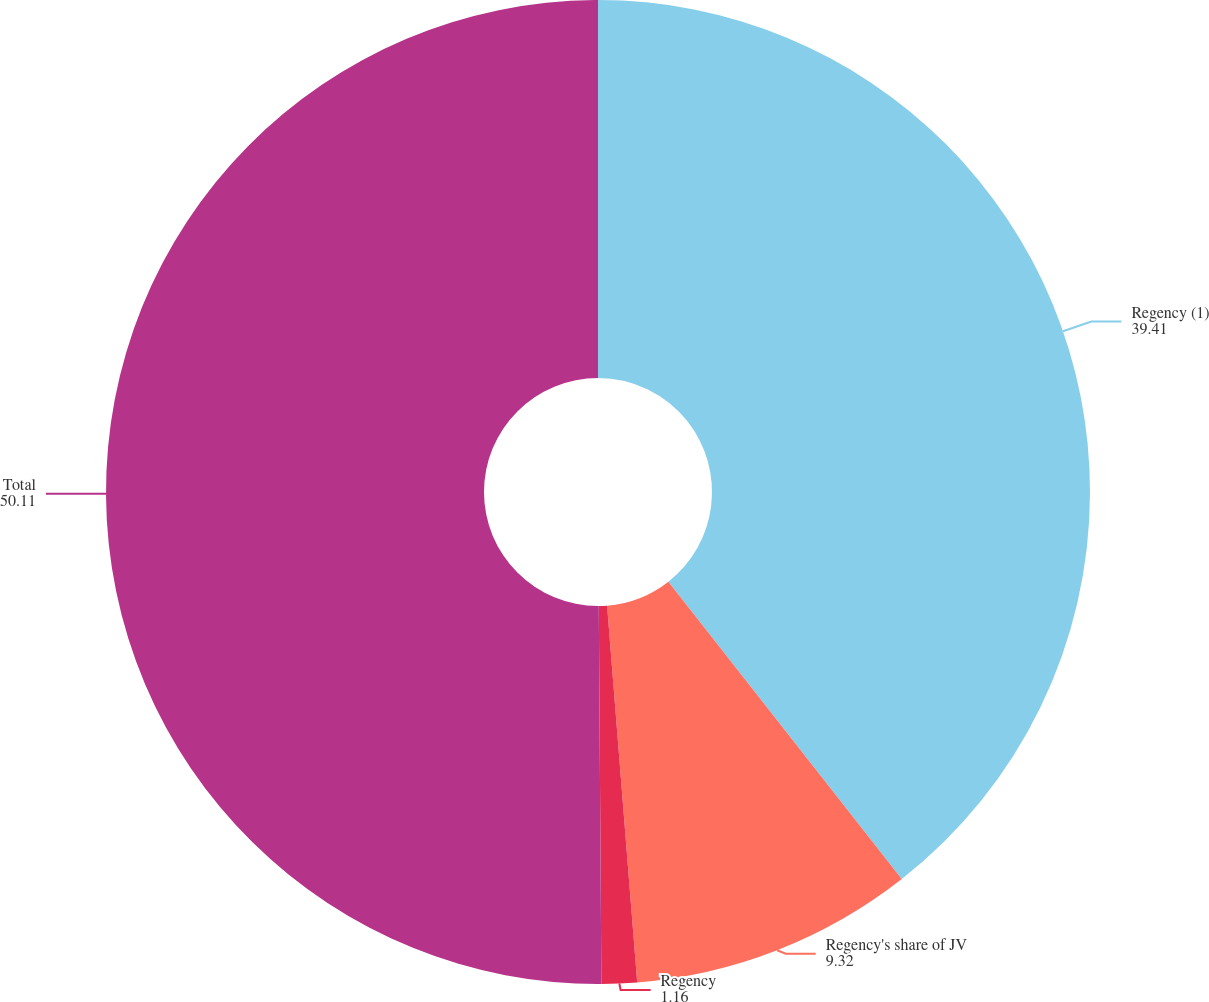<chart> <loc_0><loc_0><loc_500><loc_500><pie_chart><fcel>Regency (1)<fcel>Regency's share of JV<fcel>Regency<fcel>Total<nl><fcel>39.41%<fcel>9.32%<fcel>1.16%<fcel>50.11%<nl></chart> 